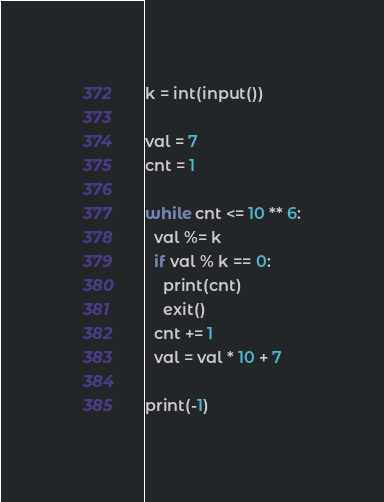<code> <loc_0><loc_0><loc_500><loc_500><_Python_>k = int(input())

val = 7
cnt = 1

while cnt <= 10 ** 6:
  val %= k
  if val % k == 0:
    print(cnt)
    exit()
  cnt += 1
  val = val * 10 + 7

print(-1)</code> 